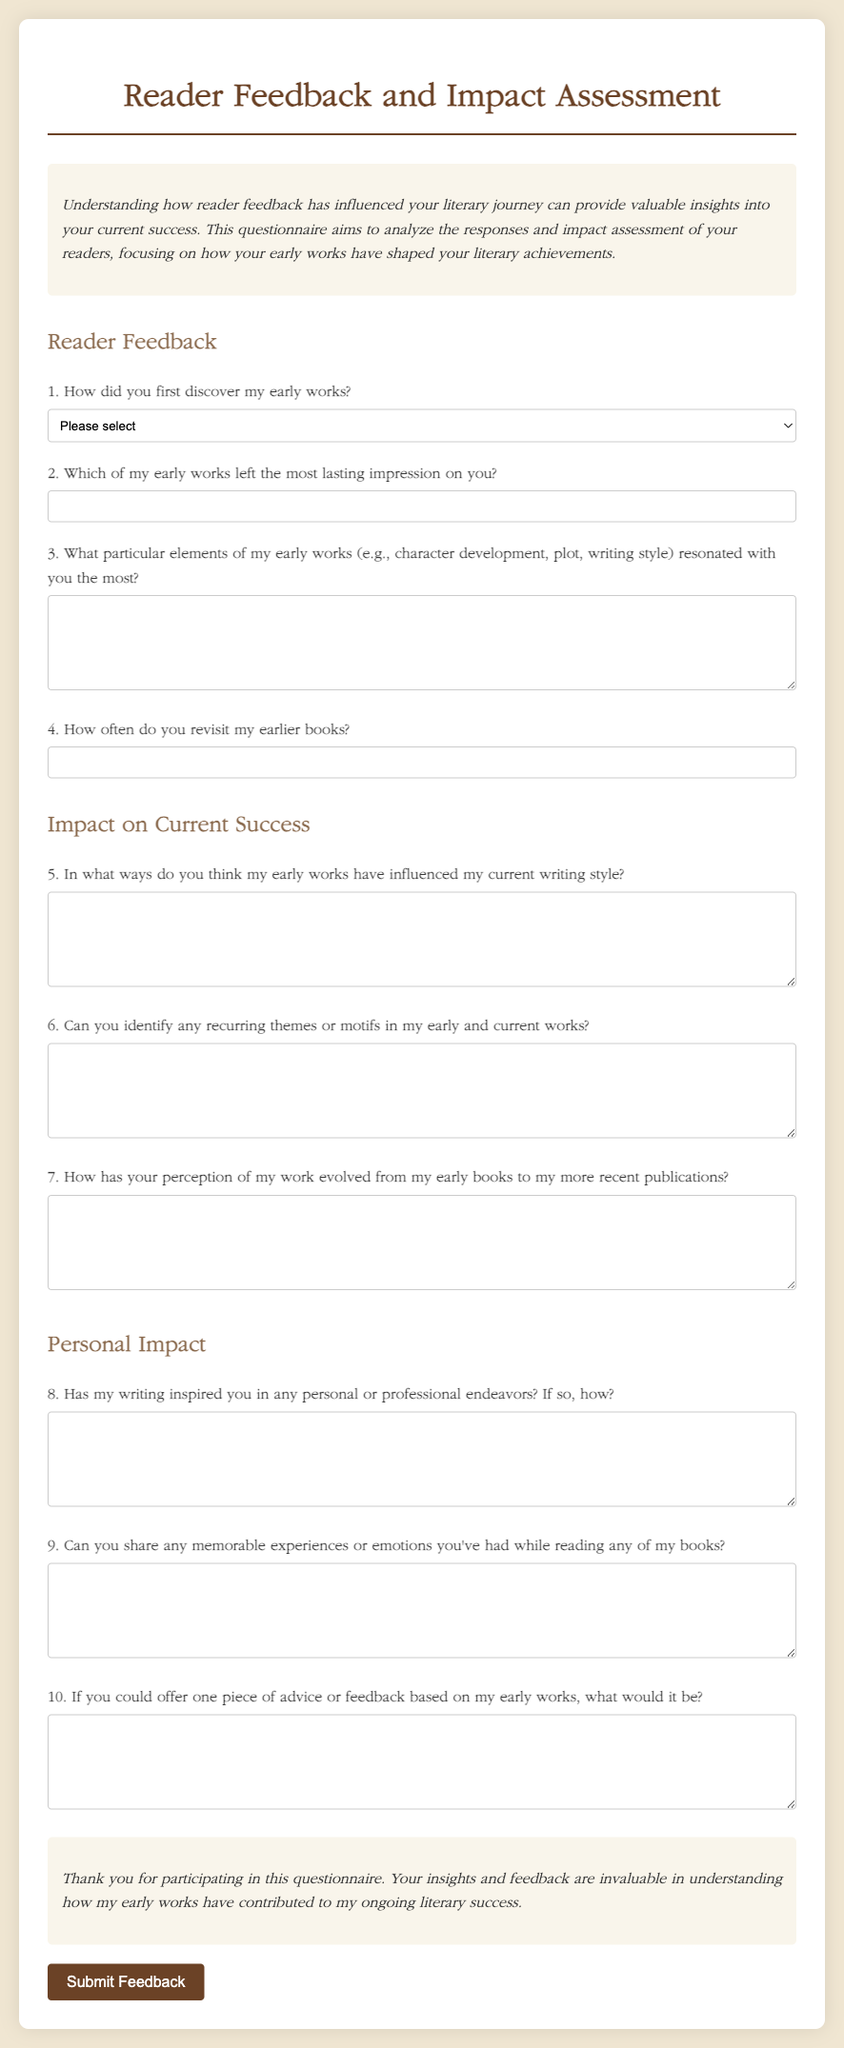What is the title of the document? The title of the document is provided in the <title> tag in the HTML head section.
Answer: Reader Feedback and Impact Assessment What is the primary color scheme used in the document's design? The primary color scheme is indicated through the CSS styles, which mention specific colors for the text and background.
Answer: Beige and brown How many sections are there in the form? The document contains headings that indicate sections, and by counting them, we find the number of sections.
Answer: Three What is the purpose of the questionnaire? The purpose is described in the introduction paragraph in the document, indicating what it aims to achieve.
Answer: To analyze responses and impact assessment Which question addresses personal journeys inspired by the author's writing? The specific question is labeled with a number in the form, asking respondents about their personal inspirations.
Answer: Question 8 What type of response format is required for question two? The response format for this question is indicated by the input type set in the form elements.
Answer: Short answer (text) How does the document style affect its readability? The style includes line-height and font choices which contribute to the overall clarity and ease of reading the text.
Answer: Improved readability How many questions are included in the "Impact on Current Success" section? The section is identified, and by counting the questions listed beneath it, we determine the total.
Answer: Three What kind of feedback does the closing section thank participants for? The closing section specifically mentions feedback that provides valuable insights.
Answer: Insights and feedback 